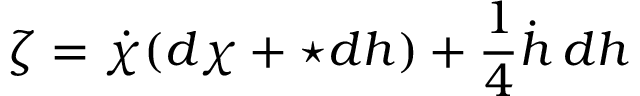Convert formula to latex. <formula><loc_0><loc_0><loc_500><loc_500>\zeta = \dot { \chi } ( d \chi + ^ { * } d h ) + \frac { 1 } { 4 } \dot { h } \, d h</formula> 